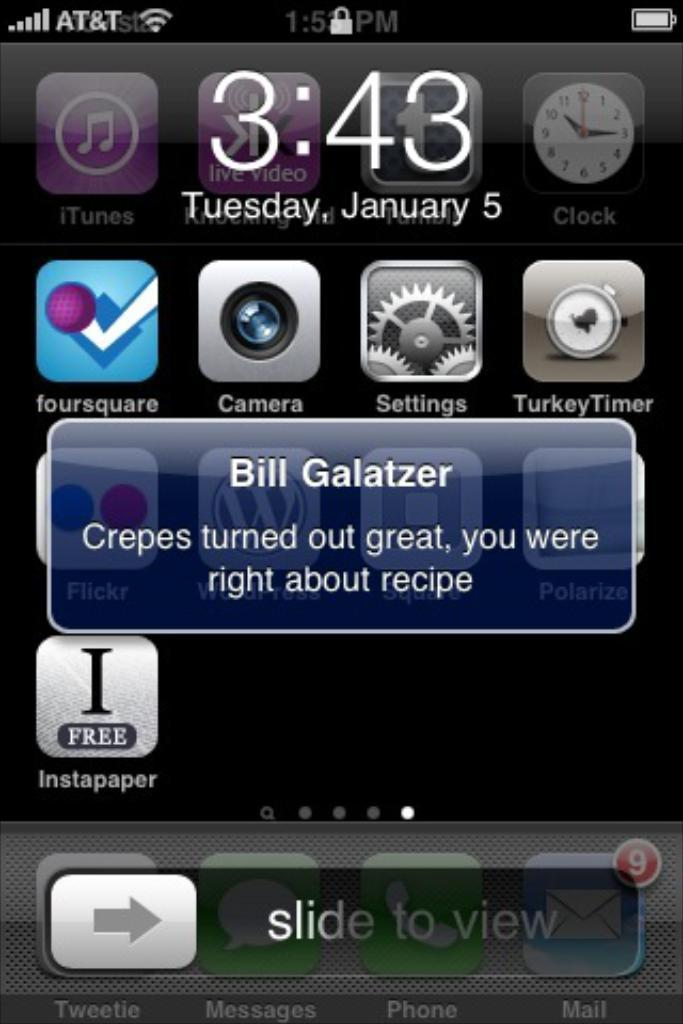<image>
Summarize the visual content of the image. A cellphone home page showing and reads a message from Bill Galatzer saying Crepes turned out great you were right about the recipe. 